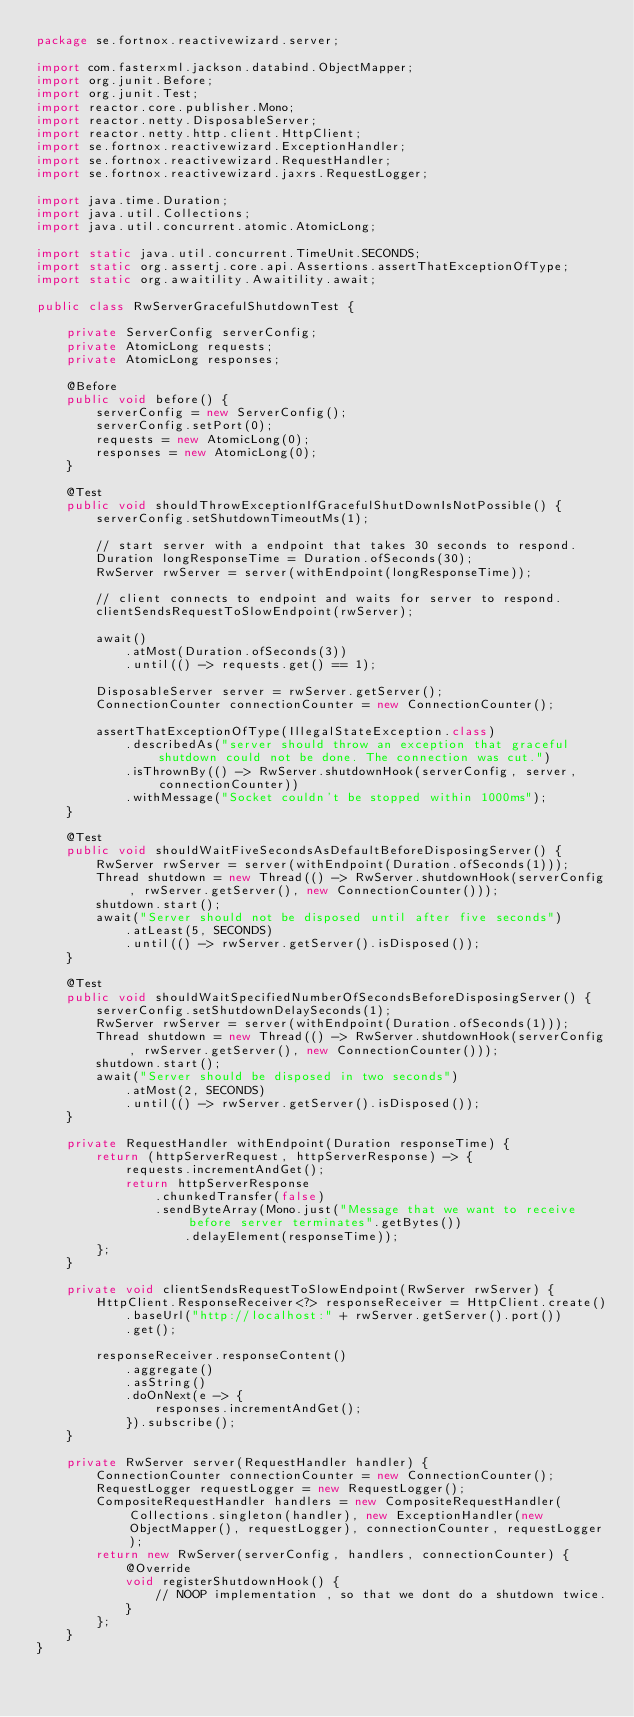Convert code to text. <code><loc_0><loc_0><loc_500><loc_500><_Java_>package se.fortnox.reactivewizard.server;

import com.fasterxml.jackson.databind.ObjectMapper;
import org.junit.Before;
import org.junit.Test;
import reactor.core.publisher.Mono;
import reactor.netty.DisposableServer;
import reactor.netty.http.client.HttpClient;
import se.fortnox.reactivewizard.ExceptionHandler;
import se.fortnox.reactivewizard.RequestHandler;
import se.fortnox.reactivewizard.jaxrs.RequestLogger;

import java.time.Duration;
import java.util.Collections;
import java.util.concurrent.atomic.AtomicLong;

import static java.util.concurrent.TimeUnit.SECONDS;
import static org.assertj.core.api.Assertions.assertThatExceptionOfType;
import static org.awaitility.Awaitility.await;

public class RwServerGracefulShutdownTest {

    private ServerConfig serverConfig;
    private AtomicLong requests;
    private AtomicLong responses;

    @Before
    public void before() {
        serverConfig = new ServerConfig();
        serverConfig.setPort(0);
        requests = new AtomicLong(0);
        responses = new AtomicLong(0);
    }

    @Test
    public void shouldThrowExceptionIfGracefulShutDownIsNotPossible() {
        serverConfig.setShutdownTimeoutMs(1);

        // start server with a endpoint that takes 30 seconds to respond.
        Duration longResponseTime = Duration.ofSeconds(30);
        RwServer rwServer = server(withEndpoint(longResponseTime));

        // client connects to endpoint and waits for server to respond.
        clientSendsRequestToSlowEndpoint(rwServer);

        await()
            .atMost(Duration.ofSeconds(3))
            .until(() -> requests.get() == 1);

        DisposableServer server = rwServer.getServer();
        ConnectionCounter connectionCounter = new ConnectionCounter();

        assertThatExceptionOfType(IllegalStateException.class)
            .describedAs("server should throw an exception that graceful shutdown could not be done. The connection was cut.")
            .isThrownBy(() -> RwServer.shutdownHook(serverConfig, server, connectionCounter))
            .withMessage("Socket couldn't be stopped within 1000ms");
    }

    @Test
    public void shouldWaitFiveSecondsAsDefaultBeforeDisposingServer() {
        RwServer rwServer = server(withEndpoint(Duration.ofSeconds(1)));
        Thread shutdown = new Thread(() -> RwServer.shutdownHook(serverConfig, rwServer.getServer(), new ConnectionCounter()));
        shutdown.start();
        await("Server should not be disposed until after five seconds")
            .atLeast(5, SECONDS)
            .until(() -> rwServer.getServer().isDisposed());
    }

    @Test
    public void shouldWaitSpecifiedNumberOfSecondsBeforeDisposingServer() {
        serverConfig.setShutdownDelaySeconds(1);
        RwServer rwServer = server(withEndpoint(Duration.ofSeconds(1)));
        Thread shutdown = new Thread(() -> RwServer.shutdownHook(serverConfig, rwServer.getServer(), new ConnectionCounter()));
        shutdown.start();
        await("Server should be disposed in two seconds")
            .atMost(2, SECONDS)
            .until(() -> rwServer.getServer().isDisposed());
    }

    private RequestHandler withEndpoint(Duration responseTime) {
        return (httpServerRequest, httpServerResponse) -> {
            requests.incrementAndGet();
            return httpServerResponse
                .chunkedTransfer(false)
                .sendByteArray(Mono.just("Message that we want to receive before server terminates".getBytes())
                    .delayElement(responseTime));
        };
    }

    private void clientSendsRequestToSlowEndpoint(RwServer rwServer) {
        HttpClient.ResponseReceiver<?> responseReceiver = HttpClient.create()
            .baseUrl("http://localhost:" + rwServer.getServer().port())
            .get();

        responseReceiver.responseContent()
            .aggregate()
            .asString()
            .doOnNext(e -> {
                responses.incrementAndGet();
            }).subscribe();
    }

    private RwServer server(RequestHandler handler) {
        ConnectionCounter connectionCounter = new ConnectionCounter();
        RequestLogger requestLogger = new RequestLogger();
        CompositeRequestHandler handlers = new CompositeRequestHandler(Collections.singleton(handler), new ExceptionHandler(new ObjectMapper(), requestLogger), connectionCounter, requestLogger);
        return new RwServer(serverConfig, handlers, connectionCounter) {
            @Override
            void registerShutdownHook() {
                // NOOP implementation , so that we dont do a shutdown twice.
            }
        };
    }
}
</code> 